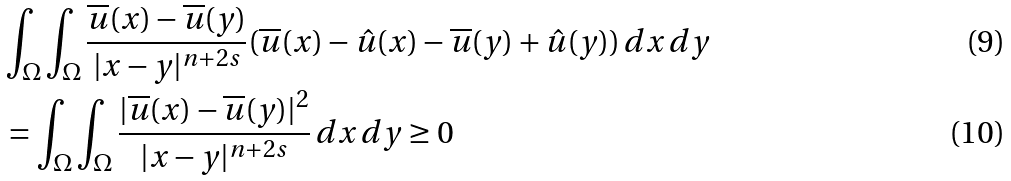Convert formula to latex. <formula><loc_0><loc_0><loc_500><loc_500>& \int _ { \Omega } { \int _ { \Omega } { \frac { \overline { u } ( x ) - \overline { u } ( y ) } { | x - y | ^ { n + 2 s } } ( \overline { u } ( x ) - \hat { u } ( x ) - \overline { u } ( y ) + \hat { u } ( y ) ) \, d x \, d y } } \\ & = \int _ { \Omega } { \int _ { \Omega } { \frac { | \overline { u } ( x ) - \overline { u } ( y ) | ^ { 2 } } { | x - y | ^ { n + 2 s } } \, d x \, d y } } \geq 0</formula> 